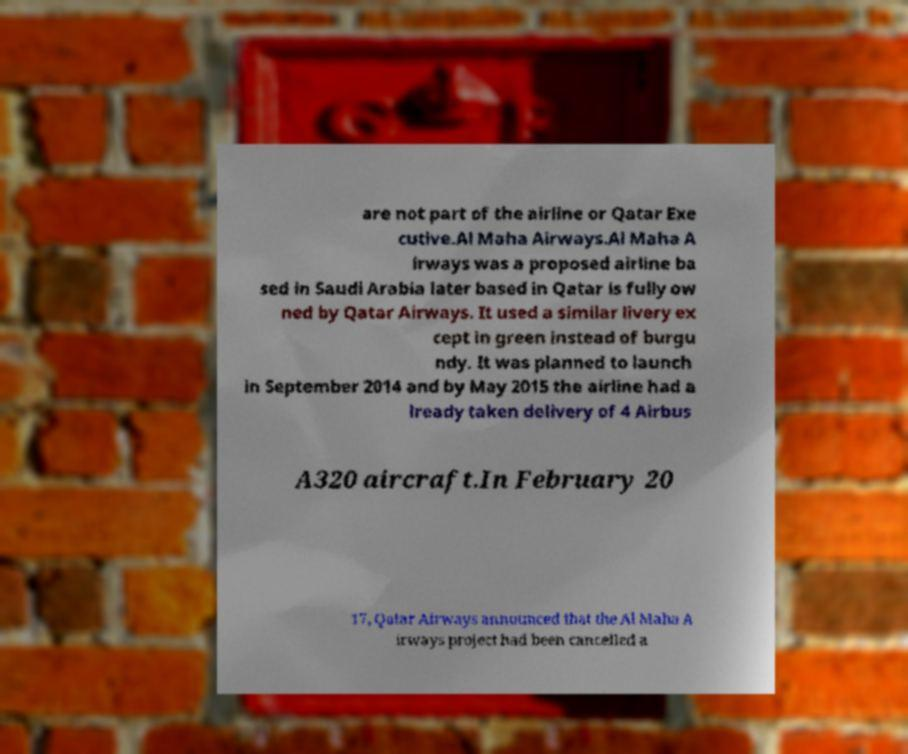For documentation purposes, I need the text within this image transcribed. Could you provide that? are not part of the airline or Qatar Exe cutive.Al Maha Airways.Al Maha A irways was a proposed airline ba sed in Saudi Arabia later based in Qatar is fully ow ned by Qatar Airways. It used a similar livery ex cept in green instead of burgu ndy. It was planned to launch in September 2014 and by May 2015 the airline had a lready taken delivery of 4 Airbus A320 aircraft.In February 20 17, Qatar Airways announced that the Al Maha A irways project had been cancelled a 